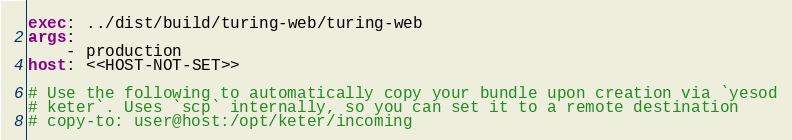<code> <loc_0><loc_0><loc_500><loc_500><_YAML_>exec: ../dist/build/turing-web/turing-web
args:
    - production
host: <<HOST-NOT-SET>>

# Use the following to automatically copy your bundle upon creation via `yesod
# keter`. Uses `scp` internally, so you can set it to a remote destination
# copy-to: user@host:/opt/keter/incoming
</code> 